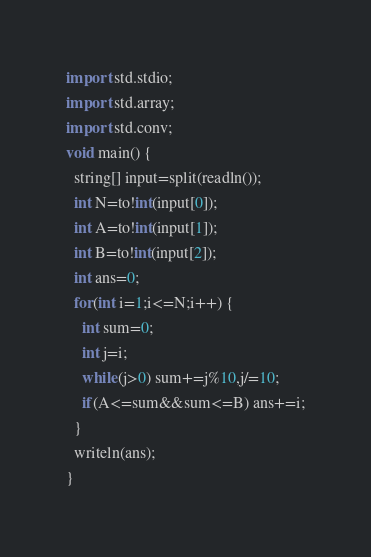Convert code to text. <code><loc_0><loc_0><loc_500><loc_500><_D_>import std.stdio;
import std.array;
import std.conv;
void main() {
  string[] input=split(readln());
  int N=to!int(input[0]);
  int A=to!int(input[1]);
  int B=to!int(input[2]);
  int ans=0;
  for(int i=1;i<=N;i++) {
    int sum=0;
    int j=i;
    while(j>0) sum+=j%10,j/=10;
    if(A<=sum&&sum<=B) ans+=i;
  }
  writeln(ans);
}
</code> 